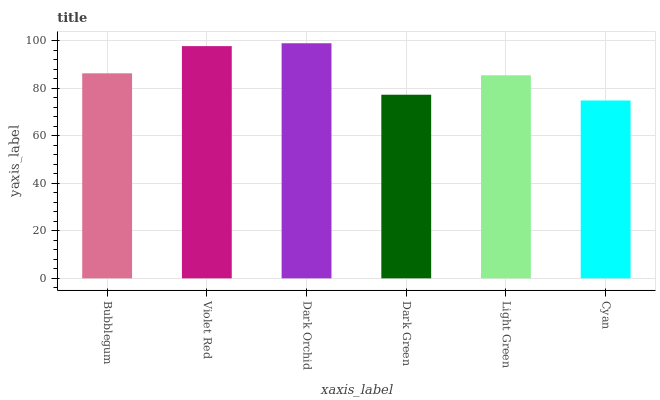Is Cyan the minimum?
Answer yes or no. Yes. Is Dark Orchid the maximum?
Answer yes or no. Yes. Is Violet Red the minimum?
Answer yes or no. No. Is Violet Red the maximum?
Answer yes or no. No. Is Violet Red greater than Bubblegum?
Answer yes or no. Yes. Is Bubblegum less than Violet Red?
Answer yes or no. Yes. Is Bubblegum greater than Violet Red?
Answer yes or no. No. Is Violet Red less than Bubblegum?
Answer yes or no. No. Is Bubblegum the high median?
Answer yes or no. Yes. Is Light Green the low median?
Answer yes or no. Yes. Is Dark Orchid the high median?
Answer yes or no. No. Is Violet Red the low median?
Answer yes or no. No. 